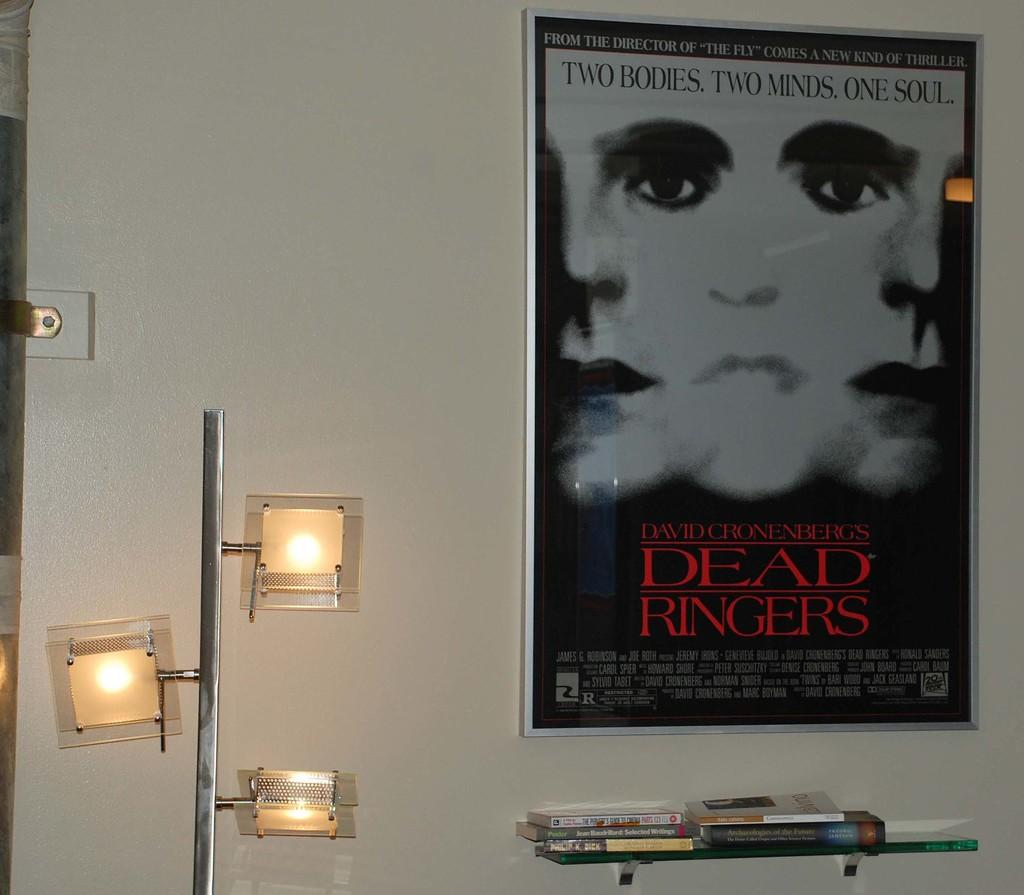<image>
Share a concise interpretation of the image provided. Dead Ringers poster hanging on a white wall. 